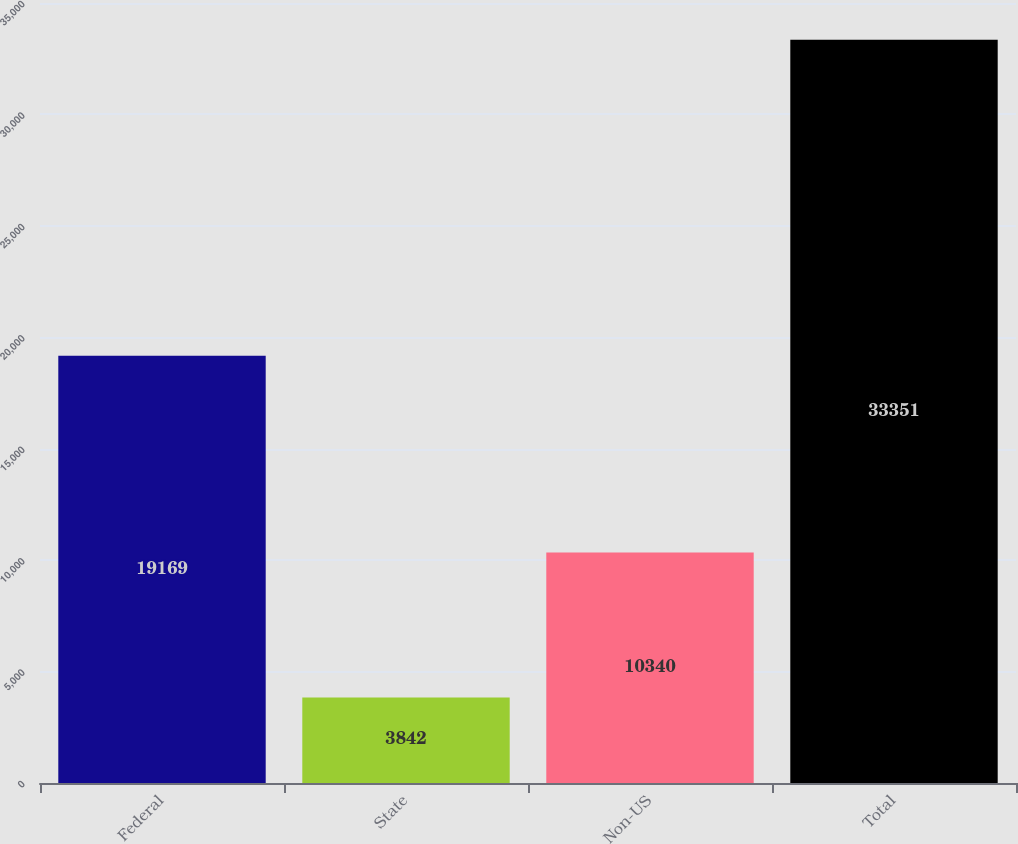<chart> <loc_0><loc_0><loc_500><loc_500><bar_chart><fcel>Federal<fcel>State<fcel>Non-US<fcel>Total<nl><fcel>19169<fcel>3842<fcel>10340<fcel>33351<nl></chart> 